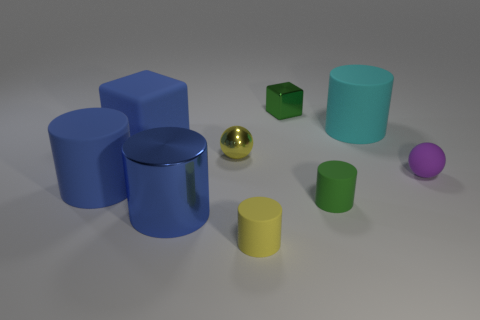Subtract all small cylinders. How many cylinders are left? 3 Add 1 red matte cylinders. How many objects exist? 10 Subtract all purple balls. How many balls are left? 1 Subtract 3 cylinders. How many cylinders are left? 2 Subtract all big blue spheres. Subtract all purple matte balls. How many objects are left? 8 Add 6 metallic cubes. How many metallic cubes are left? 7 Add 8 yellow metal objects. How many yellow metal objects exist? 9 Subtract 1 yellow cylinders. How many objects are left? 8 Subtract all blocks. How many objects are left? 7 Subtract all brown cylinders. Subtract all yellow spheres. How many cylinders are left? 5 